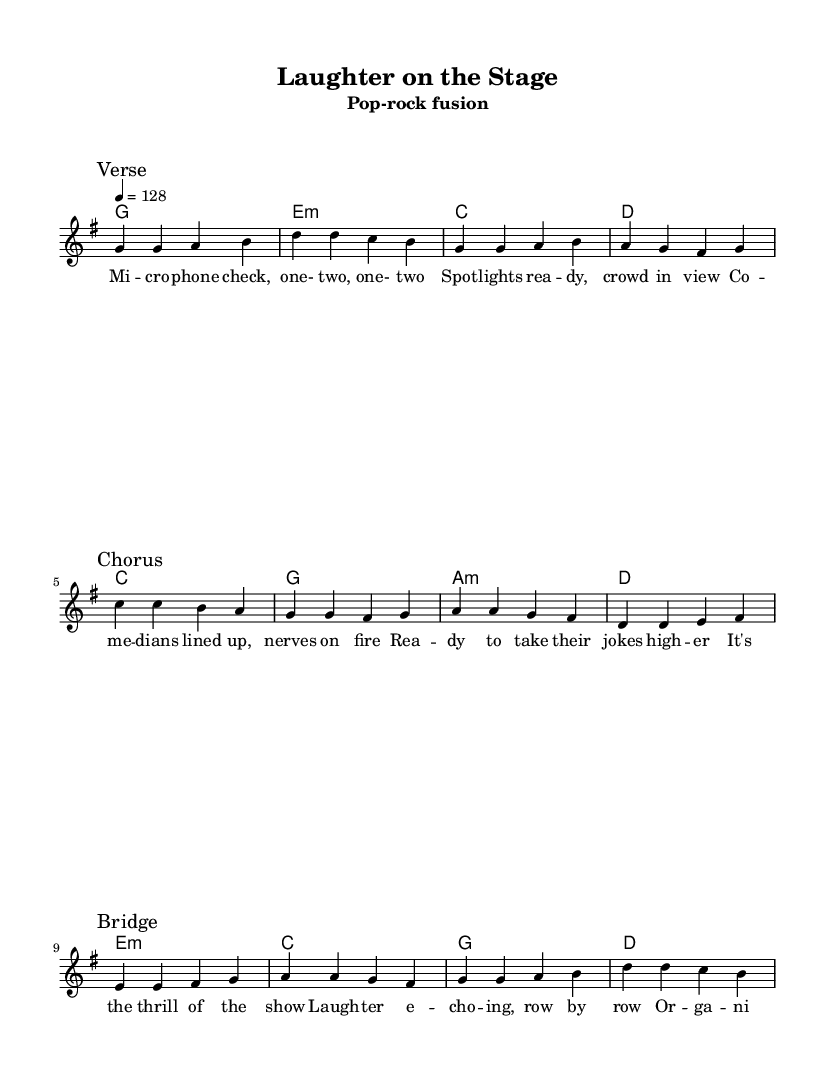What is the key signature of this music? The key signature is G major, which has one sharp (F#). This is indicated at the beginning of the sheet music where the key signature is displayed.
Answer: G major What is the time signature of this music? The time signature is 4/4, which means there are four beats in each measure and a quarter note receives one beat. This is indicated at the beginning of the score next to the clef.
Answer: 4/4 What is the tempo marking for this piece? The tempo marking is 4 equals 128, which indicates that there should be 128 beats per minute, and it is a moderately fast tempo. This is stated at the beginning where the tempo is indicated.
Answer: 128 What is the main theme of the song as reflected in the lyrics? The main theme revolves around the excitement of organizing and promoting live comedy events, emphasizing the joy and energy connected with performances. This is derived from the lyrics throughout the piece.
Answer: Thrill of the show How many sections does the song have, and what are they? The song has three main sections: Verse, Chorus, and Bridge. This can be determined by following the marked sections in the score, each divided clearly in the melody line.
Answer: Three: Verse, Chorus, Bridge What type of chords are primarily used in the verse section? The chords used in the verse section include G major, E minor, C major, and D major. These chords are outlined in the chord mode section corresponding to the melody.
Answer: G, E minor, C, D 